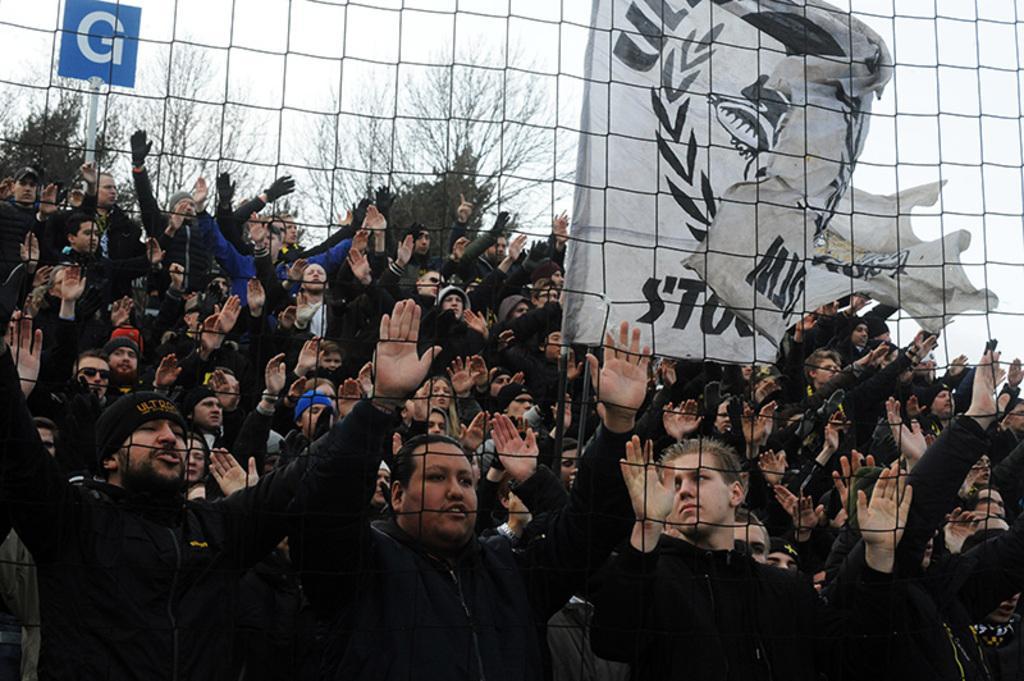Please provide a concise description of this image. In this image, we can see people standing and some are wearing caps. In the background, there are trees and we can see a board and a flag and there is mesh. 